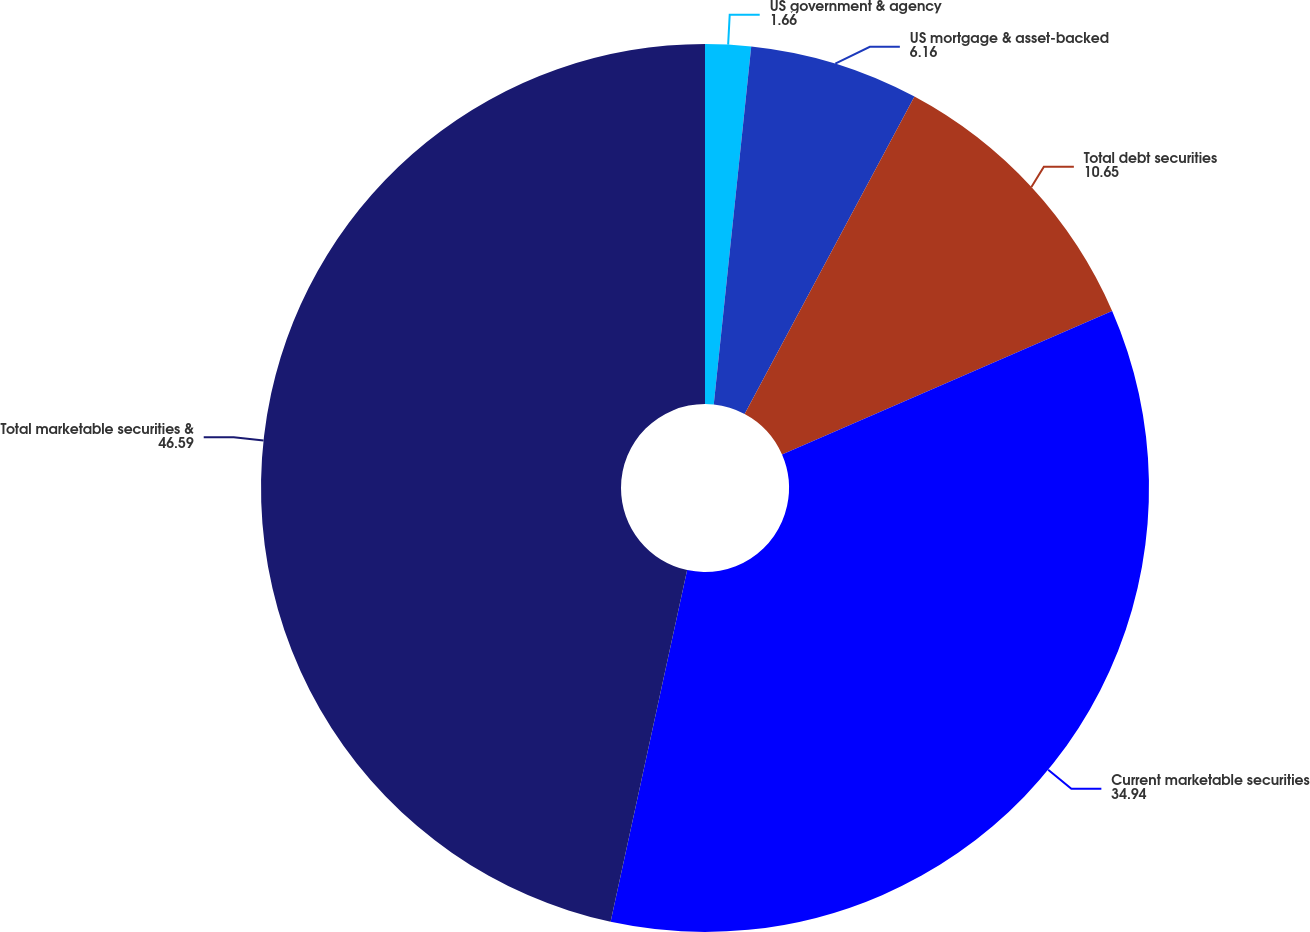<chart> <loc_0><loc_0><loc_500><loc_500><pie_chart><fcel>US government & agency<fcel>US mortgage & asset-backed<fcel>Total debt securities<fcel>Current marketable securities<fcel>Total marketable securities &<nl><fcel>1.66%<fcel>6.16%<fcel>10.65%<fcel>34.94%<fcel>46.59%<nl></chart> 